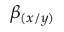<formula> <loc_0><loc_0><loc_500><loc_500>\beta _ { ( x / y ) }</formula> 